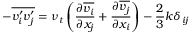Convert formula to latex. <formula><loc_0><loc_0><loc_500><loc_500>- { \overline { { v _ { i } ^ { \prime } v _ { j } ^ { \prime } } } } = \nu _ { t } \left ( { \frac { \partial { \overline { { v _ { i } } } } } { \partial x _ { j } } } + { \frac { \partial { \overline { { v _ { j } } } } } { \partial x _ { i } } } \right ) - { \frac { 2 } { 3 } } k \delta _ { i j }</formula> 